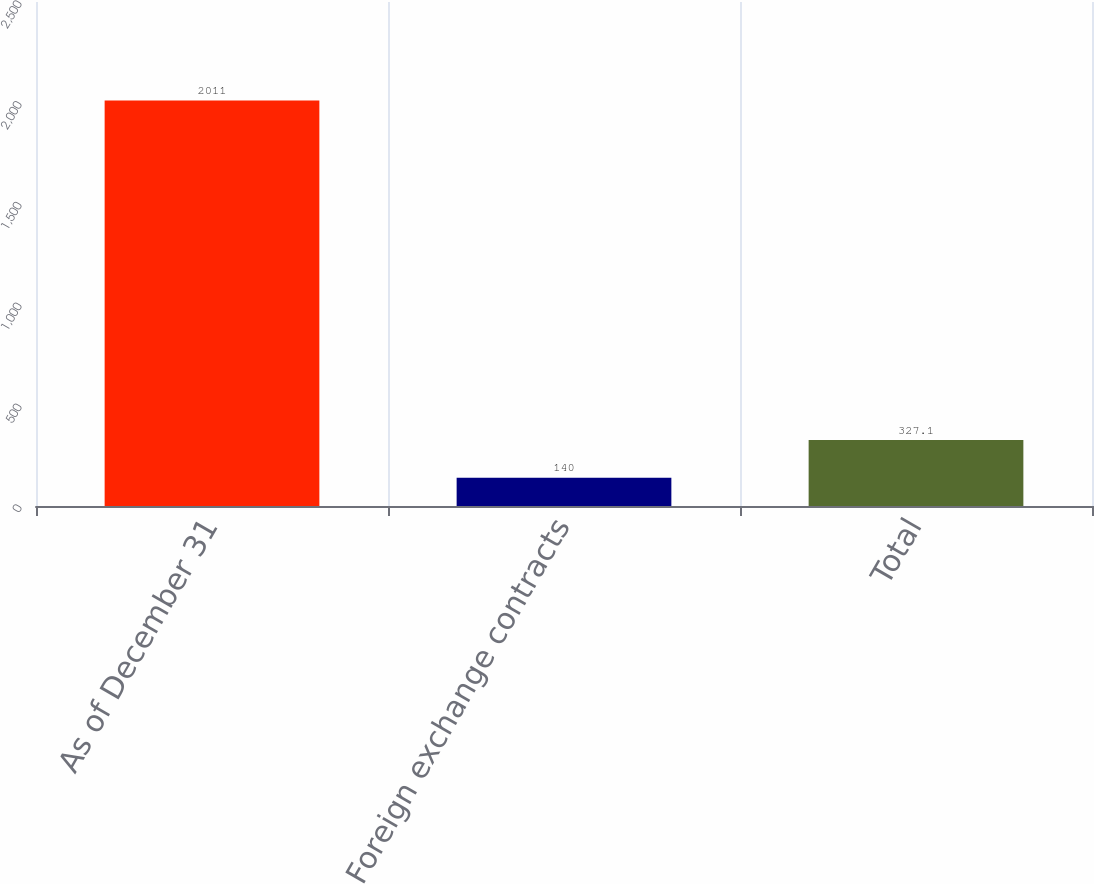Convert chart to OTSL. <chart><loc_0><loc_0><loc_500><loc_500><bar_chart><fcel>As of December 31<fcel>Foreign exchange contracts<fcel>Total<nl><fcel>2011<fcel>140<fcel>327.1<nl></chart> 